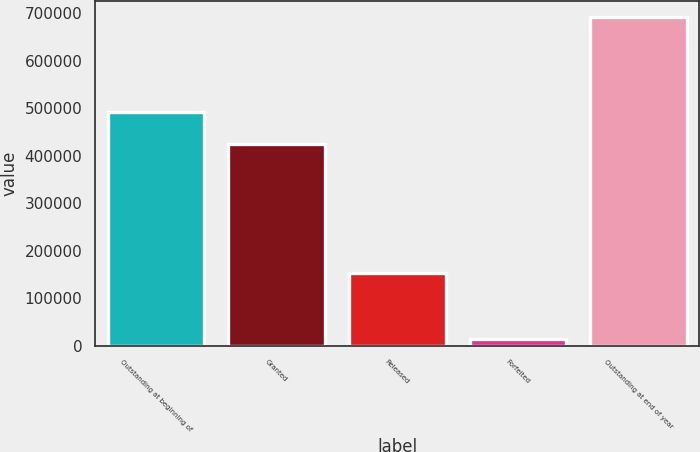Convert chart. <chart><loc_0><loc_0><loc_500><loc_500><bar_chart><fcel>Outstanding at beginning of<fcel>Granted<fcel>Released<fcel>Forfeited<fcel>Outstanding at end of year<nl><fcel>491386<fcel>423644<fcel>153200<fcel>14200<fcel>691621<nl></chart> 